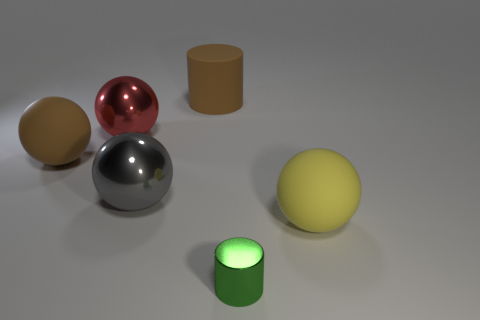Subtract all big red balls. How many balls are left? 3 Subtract all red balls. How many balls are left? 3 Subtract all cylinders. How many objects are left? 4 Subtract 3 balls. How many balls are left? 1 Subtract all brown cylinders. Subtract all purple blocks. How many cylinders are left? 1 Subtract all gray cubes. How many yellow spheres are left? 1 Subtract all brown shiny balls. Subtract all small green things. How many objects are left? 5 Add 2 big brown rubber cylinders. How many big brown rubber cylinders are left? 3 Add 3 small blocks. How many small blocks exist? 3 Add 2 big red spheres. How many objects exist? 8 